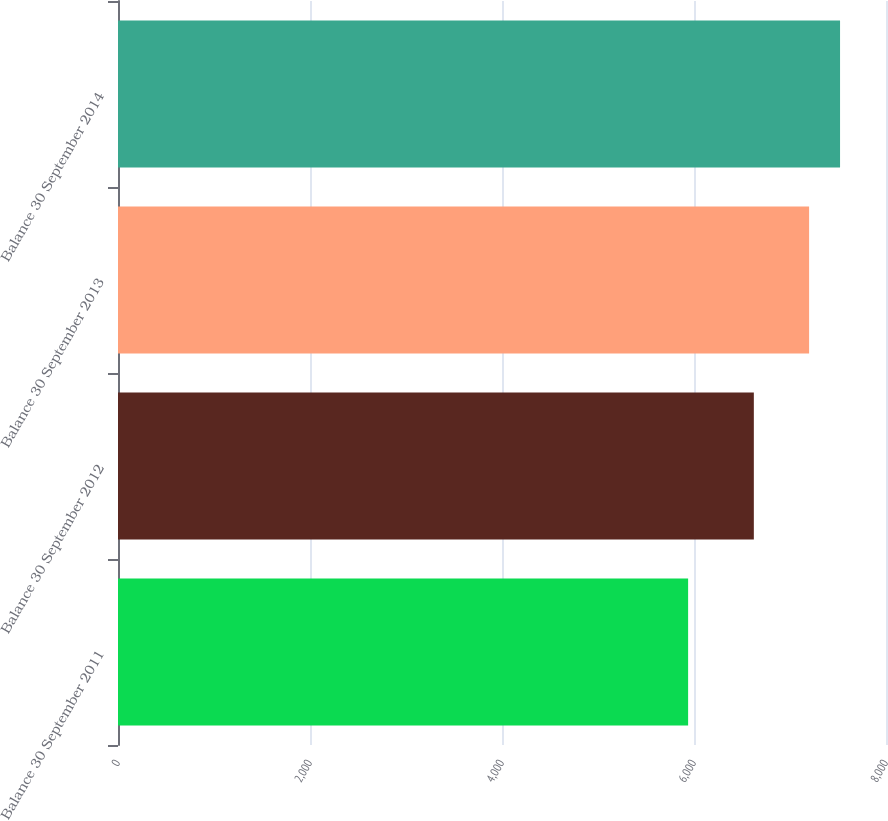<chart> <loc_0><loc_0><loc_500><loc_500><bar_chart><fcel>Balance 30 September 2011<fcel>Balance 30 September 2012<fcel>Balance 30 September 2013<fcel>Balance 30 September 2014<nl><fcel>5938.7<fcel>6623.3<fcel>7198.9<fcel>7521.4<nl></chart> 